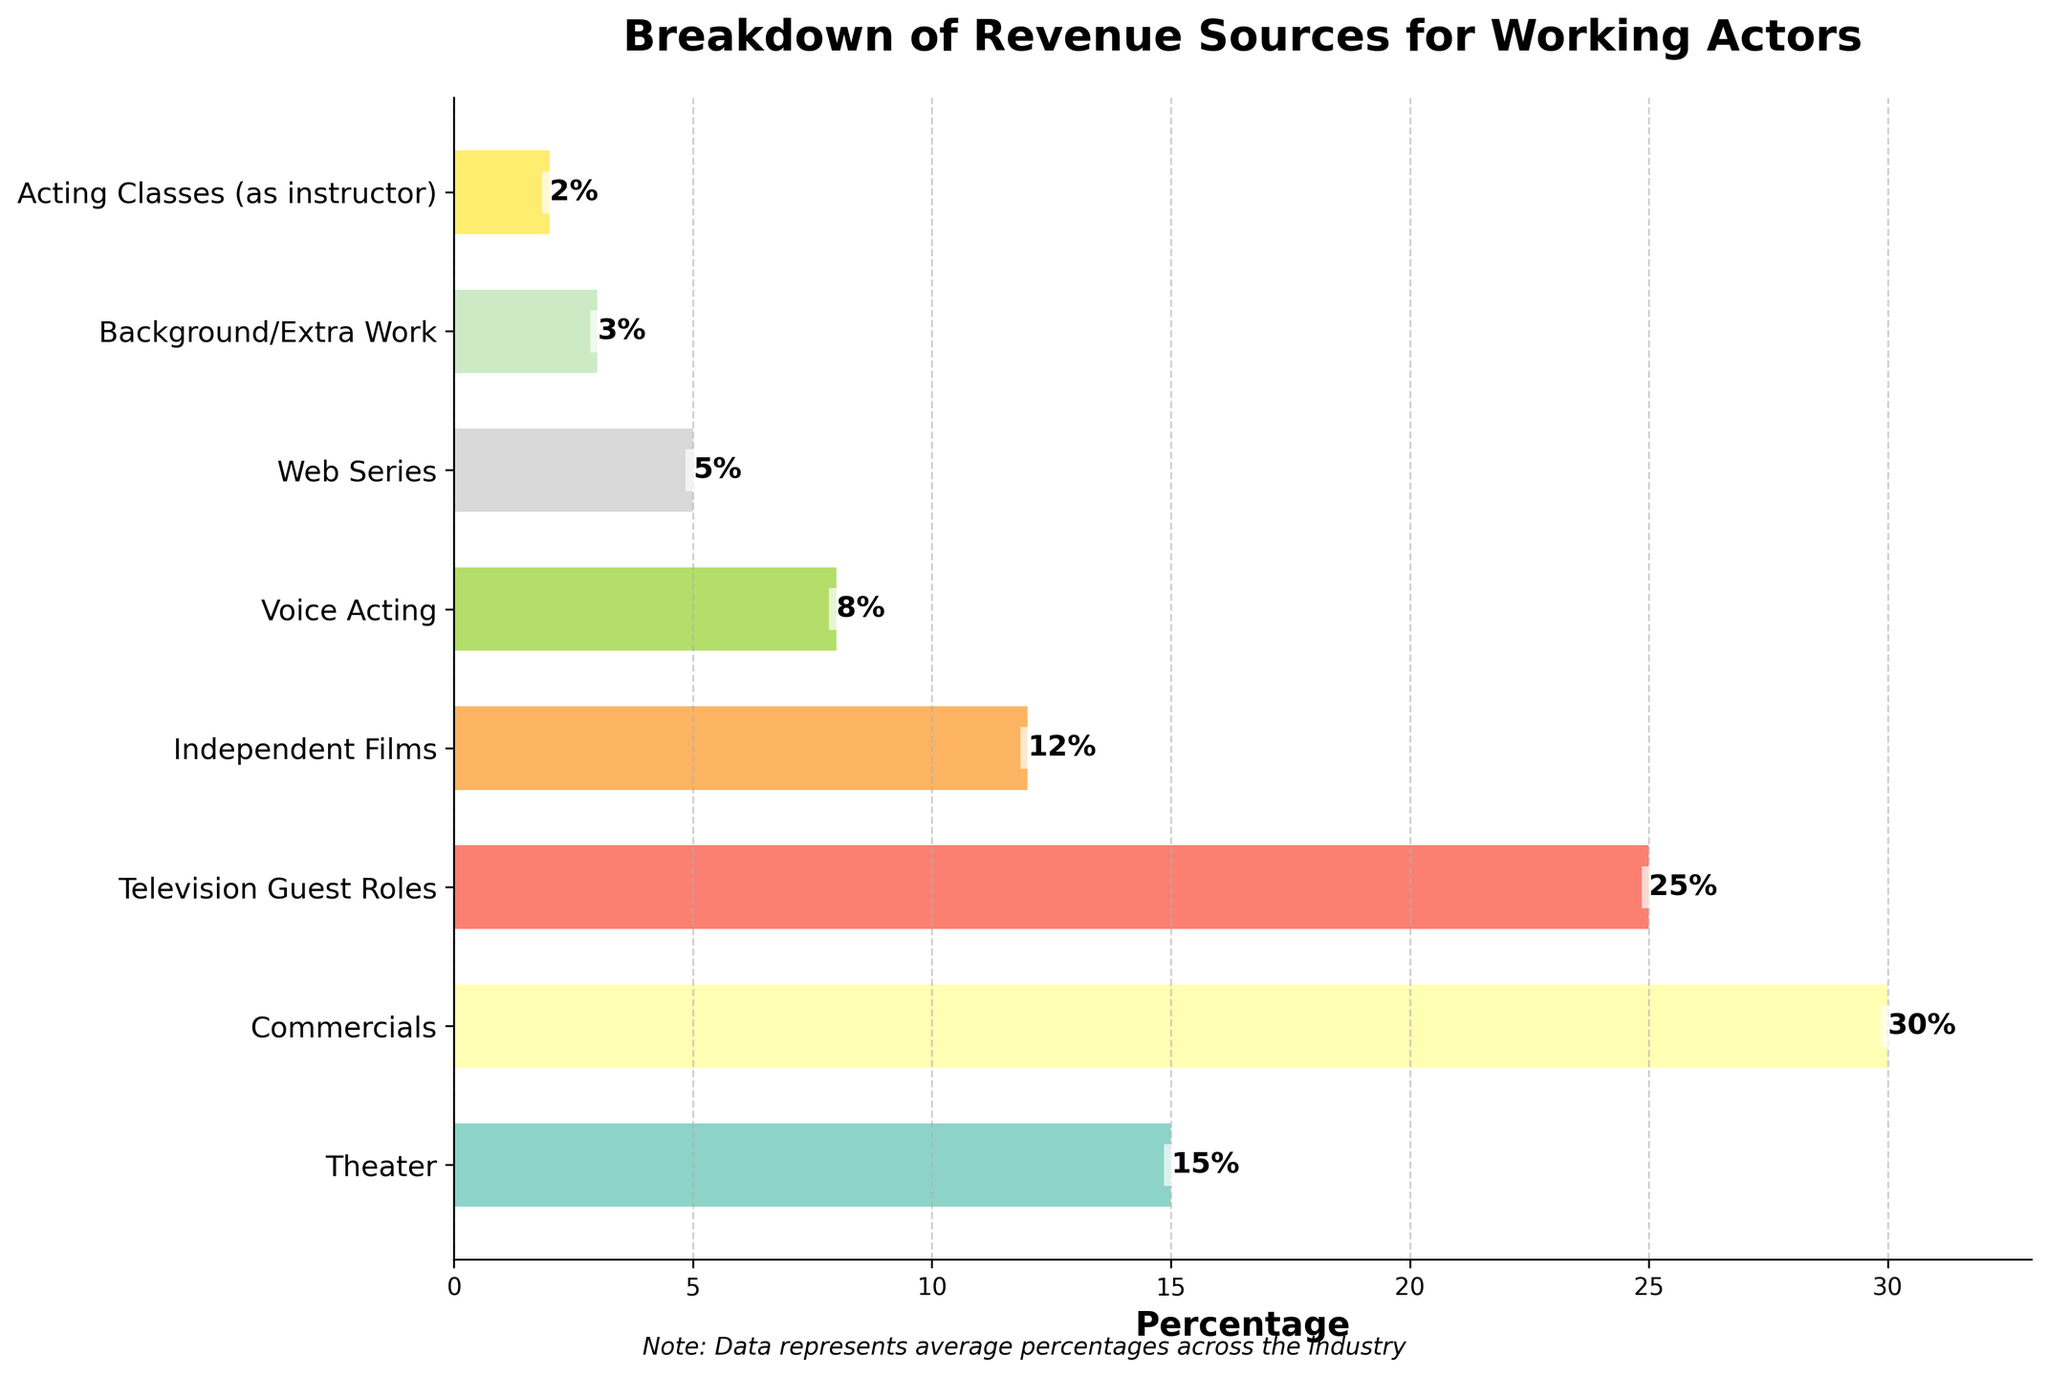Which revenue source generates the highest percentage for working actors? The bar for commercials is the longest, indicating it generates the highest percentage of revenue.
Answer: Commercials What is the combined percentage of revenue from television guest roles and independent films? Television guest roles contribute 25% and independent films contribute 12%. Adding these together: 25 + 12 = 37.
Answer: 37% Which generates more revenue for working actors: theater or voice acting? The bar for theater (15%) is longer than the bar for voice acting (8%).
Answer: Theater How much more revenue does commercials generate compared to web series? Commercials generate 30% and web series generate 5%. The difference is 30 - 5 = 25.
Answer: 25% List all revenue sources that generate less than 10% for working actors. The following bars are below 10%: voice acting (8%), web series (5%), background/extra work (3%), acting classes (as instructor) (2%).
Answer: Voice Acting, Web Series, Background/Extra Work, Acting Classes (as instructor) What is the percentage difference between the highest and lowest revenue sources? The highest revenue source is commercials at 30%, and the lowest is acting classes (as instructor) at 2%. The difference is 30 - 2 = 28.
Answer: 28% Which revenue source is exactly in the middle in terms of percentage contribution? When ordered by percentage: Acting Classes (2%), Background/Extra Work (3%), Web Series (5%), Voice Acting (8%), Independent Films (12%), Theater (15%), Television Guest Roles (25%), Commercials (30%). The middle value is `Independent Films` with 12%.
Answer: Independent Films Is the combined revenue from voice acting and background/extra work greater than that from web series? Voice acting contributes 8% and background/extra work contributes 3%, making 8 + 3 = 11%. This is greater than the 5% from web series.
Answer: Yes Which two revenue sources, when combined, equal the percentage of revenue from theater? Acting classes and background/extra work will add to 2% + 3% = 5%. Voice acting will contribute another 8% so that 5 + 8 = 13%. So, combining Web Series (5%) and Independent Films (12%) will be closest to 15%.
Answer: Web Series and Independent Films 